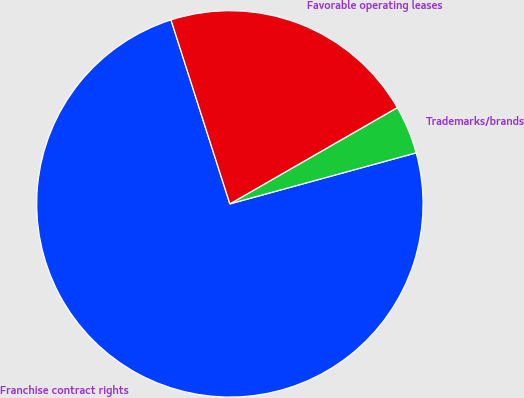Convert chart. <chart><loc_0><loc_0><loc_500><loc_500><pie_chart><fcel>Franchise contract rights<fcel>Trademarks/brands<fcel>Favorable operating leases<nl><fcel>74.32%<fcel>4.05%<fcel>21.62%<nl></chart> 